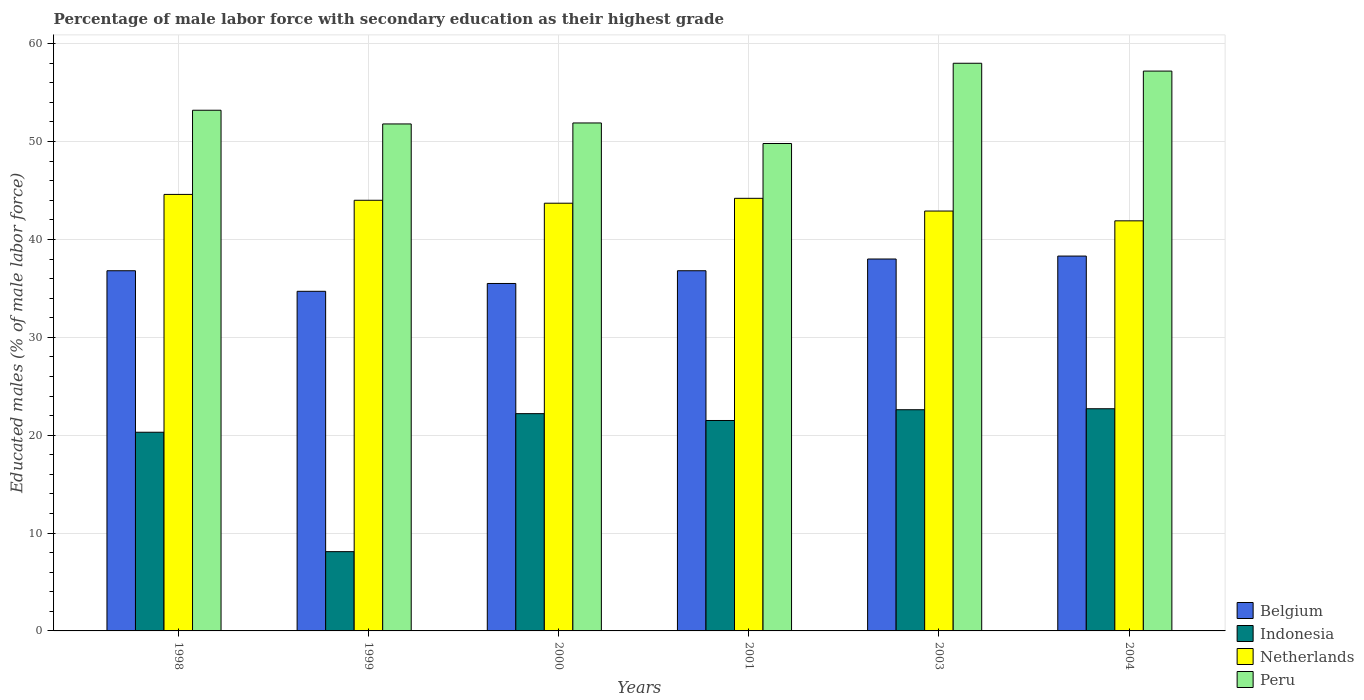How many different coloured bars are there?
Provide a short and direct response. 4. How many groups of bars are there?
Keep it short and to the point. 6. Are the number of bars on each tick of the X-axis equal?
Keep it short and to the point. Yes. How many bars are there on the 6th tick from the right?
Ensure brevity in your answer.  4. What is the label of the 2nd group of bars from the left?
Provide a short and direct response. 1999. What is the percentage of male labor force with secondary education in Belgium in 2004?
Your answer should be very brief. 38.3. Across all years, what is the maximum percentage of male labor force with secondary education in Indonesia?
Make the answer very short. 22.7. Across all years, what is the minimum percentage of male labor force with secondary education in Netherlands?
Give a very brief answer. 41.9. In which year was the percentage of male labor force with secondary education in Peru maximum?
Your response must be concise. 2003. What is the total percentage of male labor force with secondary education in Indonesia in the graph?
Provide a short and direct response. 117.4. What is the difference between the percentage of male labor force with secondary education in Belgium in 1999 and that in 2004?
Offer a very short reply. -3.6. What is the difference between the percentage of male labor force with secondary education in Indonesia in 2000 and the percentage of male labor force with secondary education in Peru in 2003?
Provide a short and direct response. -35.8. What is the average percentage of male labor force with secondary education in Netherlands per year?
Keep it short and to the point. 43.55. In the year 2001, what is the difference between the percentage of male labor force with secondary education in Indonesia and percentage of male labor force with secondary education in Peru?
Provide a short and direct response. -28.3. In how many years, is the percentage of male labor force with secondary education in Indonesia greater than 56 %?
Give a very brief answer. 0. What is the ratio of the percentage of male labor force with secondary education in Belgium in 1998 to that in 1999?
Your answer should be very brief. 1.06. Is the difference between the percentage of male labor force with secondary education in Indonesia in 1998 and 1999 greater than the difference between the percentage of male labor force with secondary education in Peru in 1998 and 1999?
Your answer should be compact. Yes. What is the difference between the highest and the second highest percentage of male labor force with secondary education in Netherlands?
Offer a very short reply. 0.4. What is the difference between the highest and the lowest percentage of male labor force with secondary education in Netherlands?
Keep it short and to the point. 2.7. In how many years, is the percentage of male labor force with secondary education in Peru greater than the average percentage of male labor force with secondary education in Peru taken over all years?
Your answer should be compact. 2. Is the sum of the percentage of male labor force with secondary education in Belgium in 2000 and 2003 greater than the maximum percentage of male labor force with secondary education in Netherlands across all years?
Provide a short and direct response. Yes. Is it the case that in every year, the sum of the percentage of male labor force with secondary education in Indonesia and percentage of male labor force with secondary education in Peru is greater than the sum of percentage of male labor force with secondary education in Netherlands and percentage of male labor force with secondary education in Belgium?
Your answer should be compact. No. What does the 3rd bar from the right in 2001 represents?
Your answer should be very brief. Indonesia. How many bars are there?
Keep it short and to the point. 24. How many years are there in the graph?
Your answer should be compact. 6. How many legend labels are there?
Give a very brief answer. 4. What is the title of the graph?
Make the answer very short. Percentage of male labor force with secondary education as their highest grade. Does "Azerbaijan" appear as one of the legend labels in the graph?
Offer a very short reply. No. What is the label or title of the X-axis?
Your response must be concise. Years. What is the label or title of the Y-axis?
Provide a short and direct response. Educated males (% of male labor force). What is the Educated males (% of male labor force) in Belgium in 1998?
Make the answer very short. 36.8. What is the Educated males (% of male labor force) in Indonesia in 1998?
Your answer should be very brief. 20.3. What is the Educated males (% of male labor force) in Netherlands in 1998?
Keep it short and to the point. 44.6. What is the Educated males (% of male labor force) in Peru in 1998?
Provide a short and direct response. 53.2. What is the Educated males (% of male labor force) in Belgium in 1999?
Your answer should be very brief. 34.7. What is the Educated males (% of male labor force) in Indonesia in 1999?
Your answer should be very brief. 8.1. What is the Educated males (% of male labor force) in Peru in 1999?
Offer a terse response. 51.8. What is the Educated males (% of male labor force) in Belgium in 2000?
Provide a short and direct response. 35.5. What is the Educated males (% of male labor force) of Indonesia in 2000?
Provide a succinct answer. 22.2. What is the Educated males (% of male labor force) of Netherlands in 2000?
Offer a terse response. 43.7. What is the Educated males (% of male labor force) of Peru in 2000?
Offer a terse response. 51.9. What is the Educated males (% of male labor force) in Belgium in 2001?
Offer a terse response. 36.8. What is the Educated males (% of male labor force) of Indonesia in 2001?
Your answer should be compact. 21.5. What is the Educated males (% of male labor force) in Netherlands in 2001?
Your answer should be compact. 44.2. What is the Educated males (% of male labor force) of Peru in 2001?
Offer a very short reply. 49.8. What is the Educated males (% of male labor force) in Belgium in 2003?
Keep it short and to the point. 38. What is the Educated males (% of male labor force) of Indonesia in 2003?
Make the answer very short. 22.6. What is the Educated males (% of male labor force) in Netherlands in 2003?
Offer a very short reply. 42.9. What is the Educated males (% of male labor force) of Belgium in 2004?
Provide a short and direct response. 38.3. What is the Educated males (% of male labor force) of Indonesia in 2004?
Make the answer very short. 22.7. What is the Educated males (% of male labor force) of Netherlands in 2004?
Ensure brevity in your answer.  41.9. What is the Educated males (% of male labor force) in Peru in 2004?
Ensure brevity in your answer.  57.2. Across all years, what is the maximum Educated males (% of male labor force) of Belgium?
Give a very brief answer. 38.3. Across all years, what is the maximum Educated males (% of male labor force) in Indonesia?
Give a very brief answer. 22.7. Across all years, what is the maximum Educated males (% of male labor force) in Netherlands?
Give a very brief answer. 44.6. Across all years, what is the minimum Educated males (% of male labor force) in Belgium?
Your answer should be compact. 34.7. Across all years, what is the minimum Educated males (% of male labor force) of Indonesia?
Offer a very short reply. 8.1. Across all years, what is the minimum Educated males (% of male labor force) of Netherlands?
Keep it short and to the point. 41.9. Across all years, what is the minimum Educated males (% of male labor force) in Peru?
Keep it short and to the point. 49.8. What is the total Educated males (% of male labor force) of Belgium in the graph?
Your answer should be compact. 220.1. What is the total Educated males (% of male labor force) in Indonesia in the graph?
Make the answer very short. 117.4. What is the total Educated males (% of male labor force) of Netherlands in the graph?
Make the answer very short. 261.3. What is the total Educated males (% of male labor force) of Peru in the graph?
Your response must be concise. 321.9. What is the difference between the Educated males (% of male labor force) of Netherlands in 1998 and that in 1999?
Your answer should be very brief. 0.6. What is the difference between the Educated males (% of male labor force) of Belgium in 1998 and that in 2000?
Your response must be concise. 1.3. What is the difference between the Educated males (% of male labor force) in Peru in 1998 and that in 2000?
Make the answer very short. 1.3. What is the difference between the Educated males (% of male labor force) in Belgium in 1998 and that in 2001?
Give a very brief answer. 0. What is the difference between the Educated males (% of male labor force) of Indonesia in 1998 and that in 2001?
Your answer should be very brief. -1.2. What is the difference between the Educated males (% of male labor force) of Netherlands in 1998 and that in 2001?
Ensure brevity in your answer.  0.4. What is the difference between the Educated males (% of male labor force) in Indonesia in 1998 and that in 2003?
Make the answer very short. -2.3. What is the difference between the Educated males (% of male labor force) in Peru in 1998 and that in 2003?
Keep it short and to the point. -4.8. What is the difference between the Educated males (% of male labor force) of Belgium in 1998 and that in 2004?
Provide a short and direct response. -1.5. What is the difference between the Educated males (% of male labor force) of Indonesia in 1998 and that in 2004?
Give a very brief answer. -2.4. What is the difference between the Educated males (% of male labor force) in Peru in 1998 and that in 2004?
Offer a very short reply. -4. What is the difference between the Educated males (% of male labor force) in Belgium in 1999 and that in 2000?
Keep it short and to the point. -0.8. What is the difference between the Educated males (% of male labor force) of Indonesia in 1999 and that in 2000?
Keep it short and to the point. -14.1. What is the difference between the Educated males (% of male labor force) of Peru in 1999 and that in 2000?
Provide a succinct answer. -0.1. What is the difference between the Educated males (% of male labor force) in Belgium in 1999 and that in 2001?
Your answer should be very brief. -2.1. What is the difference between the Educated males (% of male labor force) in Indonesia in 1999 and that in 2001?
Provide a succinct answer. -13.4. What is the difference between the Educated males (% of male labor force) of Netherlands in 1999 and that in 2001?
Provide a short and direct response. -0.2. What is the difference between the Educated males (% of male labor force) of Belgium in 1999 and that in 2003?
Provide a short and direct response. -3.3. What is the difference between the Educated males (% of male labor force) of Indonesia in 1999 and that in 2003?
Your response must be concise. -14.5. What is the difference between the Educated males (% of male labor force) of Indonesia in 1999 and that in 2004?
Offer a very short reply. -14.6. What is the difference between the Educated males (% of male labor force) in Netherlands in 2000 and that in 2001?
Your answer should be compact. -0.5. What is the difference between the Educated males (% of male labor force) in Netherlands in 2000 and that in 2003?
Provide a short and direct response. 0.8. What is the difference between the Educated males (% of male labor force) of Indonesia in 2000 and that in 2004?
Provide a succinct answer. -0.5. What is the difference between the Educated males (% of male labor force) of Netherlands in 2000 and that in 2004?
Make the answer very short. 1.8. What is the difference between the Educated males (% of male labor force) of Belgium in 2001 and that in 2003?
Provide a short and direct response. -1.2. What is the difference between the Educated males (% of male labor force) in Indonesia in 2001 and that in 2003?
Keep it short and to the point. -1.1. What is the difference between the Educated males (% of male labor force) of Netherlands in 2001 and that in 2003?
Keep it short and to the point. 1.3. What is the difference between the Educated males (% of male labor force) in Belgium in 2001 and that in 2004?
Make the answer very short. -1.5. What is the difference between the Educated males (% of male labor force) of Indonesia in 2001 and that in 2004?
Provide a short and direct response. -1.2. What is the difference between the Educated males (% of male labor force) in Peru in 2001 and that in 2004?
Offer a very short reply. -7.4. What is the difference between the Educated males (% of male labor force) of Netherlands in 2003 and that in 2004?
Your answer should be compact. 1. What is the difference between the Educated males (% of male labor force) of Peru in 2003 and that in 2004?
Your answer should be very brief. 0.8. What is the difference between the Educated males (% of male labor force) of Belgium in 1998 and the Educated males (% of male labor force) of Indonesia in 1999?
Your response must be concise. 28.7. What is the difference between the Educated males (% of male labor force) of Belgium in 1998 and the Educated males (% of male labor force) of Netherlands in 1999?
Your answer should be compact. -7.2. What is the difference between the Educated males (% of male labor force) in Indonesia in 1998 and the Educated males (% of male labor force) in Netherlands in 1999?
Offer a terse response. -23.7. What is the difference between the Educated males (% of male labor force) of Indonesia in 1998 and the Educated males (% of male labor force) of Peru in 1999?
Your response must be concise. -31.5. What is the difference between the Educated males (% of male labor force) in Belgium in 1998 and the Educated males (% of male labor force) in Indonesia in 2000?
Keep it short and to the point. 14.6. What is the difference between the Educated males (% of male labor force) in Belgium in 1998 and the Educated males (% of male labor force) in Netherlands in 2000?
Your response must be concise. -6.9. What is the difference between the Educated males (% of male labor force) in Belgium in 1998 and the Educated males (% of male labor force) in Peru in 2000?
Make the answer very short. -15.1. What is the difference between the Educated males (% of male labor force) of Indonesia in 1998 and the Educated males (% of male labor force) of Netherlands in 2000?
Make the answer very short. -23.4. What is the difference between the Educated males (% of male labor force) in Indonesia in 1998 and the Educated males (% of male labor force) in Peru in 2000?
Offer a very short reply. -31.6. What is the difference between the Educated males (% of male labor force) of Netherlands in 1998 and the Educated males (% of male labor force) of Peru in 2000?
Provide a succinct answer. -7.3. What is the difference between the Educated males (% of male labor force) in Belgium in 1998 and the Educated males (% of male labor force) in Indonesia in 2001?
Your answer should be compact. 15.3. What is the difference between the Educated males (% of male labor force) of Belgium in 1998 and the Educated males (% of male labor force) of Peru in 2001?
Provide a short and direct response. -13. What is the difference between the Educated males (% of male labor force) of Indonesia in 1998 and the Educated males (% of male labor force) of Netherlands in 2001?
Offer a very short reply. -23.9. What is the difference between the Educated males (% of male labor force) in Indonesia in 1998 and the Educated males (% of male labor force) in Peru in 2001?
Your answer should be very brief. -29.5. What is the difference between the Educated males (% of male labor force) of Netherlands in 1998 and the Educated males (% of male labor force) of Peru in 2001?
Your response must be concise. -5.2. What is the difference between the Educated males (% of male labor force) in Belgium in 1998 and the Educated males (% of male labor force) in Indonesia in 2003?
Your answer should be compact. 14.2. What is the difference between the Educated males (% of male labor force) in Belgium in 1998 and the Educated males (% of male labor force) in Netherlands in 2003?
Ensure brevity in your answer.  -6.1. What is the difference between the Educated males (% of male labor force) in Belgium in 1998 and the Educated males (% of male labor force) in Peru in 2003?
Offer a very short reply. -21.2. What is the difference between the Educated males (% of male labor force) of Indonesia in 1998 and the Educated males (% of male labor force) of Netherlands in 2003?
Your answer should be very brief. -22.6. What is the difference between the Educated males (% of male labor force) of Indonesia in 1998 and the Educated males (% of male labor force) of Peru in 2003?
Make the answer very short. -37.7. What is the difference between the Educated males (% of male labor force) of Netherlands in 1998 and the Educated males (% of male labor force) of Peru in 2003?
Keep it short and to the point. -13.4. What is the difference between the Educated males (% of male labor force) of Belgium in 1998 and the Educated males (% of male labor force) of Peru in 2004?
Keep it short and to the point. -20.4. What is the difference between the Educated males (% of male labor force) in Indonesia in 1998 and the Educated males (% of male labor force) in Netherlands in 2004?
Offer a terse response. -21.6. What is the difference between the Educated males (% of male labor force) of Indonesia in 1998 and the Educated males (% of male labor force) of Peru in 2004?
Offer a terse response. -36.9. What is the difference between the Educated males (% of male labor force) in Netherlands in 1998 and the Educated males (% of male labor force) in Peru in 2004?
Your response must be concise. -12.6. What is the difference between the Educated males (% of male labor force) in Belgium in 1999 and the Educated males (% of male labor force) in Indonesia in 2000?
Keep it short and to the point. 12.5. What is the difference between the Educated males (% of male labor force) of Belgium in 1999 and the Educated males (% of male labor force) of Netherlands in 2000?
Offer a terse response. -9. What is the difference between the Educated males (% of male labor force) of Belgium in 1999 and the Educated males (% of male labor force) of Peru in 2000?
Keep it short and to the point. -17.2. What is the difference between the Educated males (% of male labor force) in Indonesia in 1999 and the Educated males (% of male labor force) in Netherlands in 2000?
Your answer should be compact. -35.6. What is the difference between the Educated males (% of male labor force) of Indonesia in 1999 and the Educated males (% of male labor force) of Peru in 2000?
Ensure brevity in your answer.  -43.8. What is the difference between the Educated males (% of male labor force) in Netherlands in 1999 and the Educated males (% of male labor force) in Peru in 2000?
Offer a very short reply. -7.9. What is the difference between the Educated males (% of male labor force) of Belgium in 1999 and the Educated males (% of male labor force) of Peru in 2001?
Your answer should be compact. -15.1. What is the difference between the Educated males (% of male labor force) in Indonesia in 1999 and the Educated males (% of male labor force) in Netherlands in 2001?
Provide a short and direct response. -36.1. What is the difference between the Educated males (% of male labor force) in Indonesia in 1999 and the Educated males (% of male labor force) in Peru in 2001?
Your answer should be compact. -41.7. What is the difference between the Educated males (% of male labor force) in Netherlands in 1999 and the Educated males (% of male labor force) in Peru in 2001?
Offer a terse response. -5.8. What is the difference between the Educated males (% of male labor force) of Belgium in 1999 and the Educated males (% of male labor force) of Netherlands in 2003?
Provide a short and direct response. -8.2. What is the difference between the Educated males (% of male labor force) of Belgium in 1999 and the Educated males (% of male labor force) of Peru in 2003?
Give a very brief answer. -23.3. What is the difference between the Educated males (% of male labor force) in Indonesia in 1999 and the Educated males (% of male labor force) in Netherlands in 2003?
Ensure brevity in your answer.  -34.8. What is the difference between the Educated males (% of male labor force) of Indonesia in 1999 and the Educated males (% of male labor force) of Peru in 2003?
Your answer should be compact. -49.9. What is the difference between the Educated males (% of male labor force) of Belgium in 1999 and the Educated males (% of male labor force) of Indonesia in 2004?
Your answer should be very brief. 12. What is the difference between the Educated males (% of male labor force) of Belgium in 1999 and the Educated males (% of male labor force) of Netherlands in 2004?
Make the answer very short. -7.2. What is the difference between the Educated males (% of male labor force) in Belgium in 1999 and the Educated males (% of male labor force) in Peru in 2004?
Offer a very short reply. -22.5. What is the difference between the Educated males (% of male labor force) of Indonesia in 1999 and the Educated males (% of male labor force) of Netherlands in 2004?
Offer a terse response. -33.8. What is the difference between the Educated males (% of male labor force) of Indonesia in 1999 and the Educated males (% of male labor force) of Peru in 2004?
Offer a very short reply. -49.1. What is the difference between the Educated males (% of male labor force) in Netherlands in 1999 and the Educated males (% of male labor force) in Peru in 2004?
Offer a very short reply. -13.2. What is the difference between the Educated males (% of male labor force) in Belgium in 2000 and the Educated males (% of male labor force) in Peru in 2001?
Provide a succinct answer. -14.3. What is the difference between the Educated males (% of male labor force) in Indonesia in 2000 and the Educated males (% of male labor force) in Netherlands in 2001?
Keep it short and to the point. -22. What is the difference between the Educated males (% of male labor force) in Indonesia in 2000 and the Educated males (% of male labor force) in Peru in 2001?
Provide a succinct answer. -27.6. What is the difference between the Educated males (% of male labor force) of Belgium in 2000 and the Educated males (% of male labor force) of Peru in 2003?
Your answer should be compact. -22.5. What is the difference between the Educated males (% of male labor force) of Indonesia in 2000 and the Educated males (% of male labor force) of Netherlands in 2003?
Offer a terse response. -20.7. What is the difference between the Educated males (% of male labor force) of Indonesia in 2000 and the Educated males (% of male labor force) of Peru in 2003?
Offer a very short reply. -35.8. What is the difference between the Educated males (% of male labor force) of Netherlands in 2000 and the Educated males (% of male labor force) of Peru in 2003?
Keep it short and to the point. -14.3. What is the difference between the Educated males (% of male labor force) of Belgium in 2000 and the Educated males (% of male labor force) of Netherlands in 2004?
Your answer should be very brief. -6.4. What is the difference between the Educated males (% of male labor force) in Belgium in 2000 and the Educated males (% of male labor force) in Peru in 2004?
Your answer should be very brief. -21.7. What is the difference between the Educated males (% of male labor force) in Indonesia in 2000 and the Educated males (% of male labor force) in Netherlands in 2004?
Your answer should be very brief. -19.7. What is the difference between the Educated males (% of male labor force) in Indonesia in 2000 and the Educated males (% of male labor force) in Peru in 2004?
Offer a very short reply. -35. What is the difference between the Educated males (% of male labor force) of Netherlands in 2000 and the Educated males (% of male labor force) of Peru in 2004?
Your answer should be very brief. -13.5. What is the difference between the Educated males (% of male labor force) of Belgium in 2001 and the Educated males (% of male labor force) of Indonesia in 2003?
Ensure brevity in your answer.  14.2. What is the difference between the Educated males (% of male labor force) in Belgium in 2001 and the Educated males (% of male labor force) in Netherlands in 2003?
Offer a terse response. -6.1. What is the difference between the Educated males (% of male labor force) in Belgium in 2001 and the Educated males (% of male labor force) in Peru in 2003?
Your response must be concise. -21.2. What is the difference between the Educated males (% of male labor force) in Indonesia in 2001 and the Educated males (% of male labor force) in Netherlands in 2003?
Ensure brevity in your answer.  -21.4. What is the difference between the Educated males (% of male labor force) in Indonesia in 2001 and the Educated males (% of male labor force) in Peru in 2003?
Provide a short and direct response. -36.5. What is the difference between the Educated males (% of male labor force) in Belgium in 2001 and the Educated males (% of male labor force) in Indonesia in 2004?
Your answer should be compact. 14.1. What is the difference between the Educated males (% of male labor force) of Belgium in 2001 and the Educated males (% of male labor force) of Netherlands in 2004?
Keep it short and to the point. -5.1. What is the difference between the Educated males (% of male labor force) of Belgium in 2001 and the Educated males (% of male labor force) of Peru in 2004?
Ensure brevity in your answer.  -20.4. What is the difference between the Educated males (% of male labor force) in Indonesia in 2001 and the Educated males (% of male labor force) in Netherlands in 2004?
Offer a terse response. -20.4. What is the difference between the Educated males (% of male labor force) of Indonesia in 2001 and the Educated males (% of male labor force) of Peru in 2004?
Offer a very short reply. -35.7. What is the difference between the Educated males (% of male labor force) in Netherlands in 2001 and the Educated males (% of male labor force) in Peru in 2004?
Your response must be concise. -13. What is the difference between the Educated males (% of male labor force) in Belgium in 2003 and the Educated males (% of male labor force) in Indonesia in 2004?
Keep it short and to the point. 15.3. What is the difference between the Educated males (% of male labor force) in Belgium in 2003 and the Educated males (% of male labor force) in Peru in 2004?
Your answer should be very brief. -19.2. What is the difference between the Educated males (% of male labor force) in Indonesia in 2003 and the Educated males (% of male labor force) in Netherlands in 2004?
Your response must be concise. -19.3. What is the difference between the Educated males (% of male labor force) of Indonesia in 2003 and the Educated males (% of male labor force) of Peru in 2004?
Provide a succinct answer. -34.6. What is the difference between the Educated males (% of male labor force) in Netherlands in 2003 and the Educated males (% of male labor force) in Peru in 2004?
Offer a terse response. -14.3. What is the average Educated males (% of male labor force) in Belgium per year?
Provide a short and direct response. 36.68. What is the average Educated males (% of male labor force) of Indonesia per year?
Provide a succinct answer. 19.57. What is the average Educated males (% of male labor force) of Netherlands per year?
Provide a short and direct response. 43.55. What is the average Educated males (% of male labor force) in Peru per year?
Your answer should be compact. 53.65. In the year 1998, what is the difference between the Educated males (% of male labor force) in Belgium and Educated males (% of male labor force) in Indonesia?
Give a very brief answer. 16.5. In the year 1998, what is the difference between the Educated males (% of male labor force) of Belgium and Educated males (% of male labor force) of Peru?
Your answer should be very brief. -16.4. In the year 1998, what is the difference between the Educated males (% of male labor force) of Indonesia and Educated males (% of male labor force) of Netherlands?
Offer a very short reply. -24.3. In the year 1998, what is the difference between the Educated males (% of male labor force) in Indonesia and Educated males (% of male labor force) in Peru?
Offer a terse response. -32.9. In the year 1998, what is the difference between the Educated males (% of male labor force) of Netherlands and Educated males (% of male labor force) of Peru?
Provide a short and direct response. -8.6. In the year 1999, what is the difference between the Educated males (% of male labor force) in Belgium and Educated males (% of male labor force) in Indonesia?
Keep it short and to the point. 26.6. In the year 1999, what is the difference between the Educated males (% of male labor force) of Belgium and Educated males (% of male labor force) of Netherlands?
Ensure brevity in your answer.  -9.3. In the year 1999, what is the difference between the Educated males (% of male labor force) of Belgium and Educated males (% of male labor force) of Peru?
Provide a succinct answer. -17.1. In the year 1999, what is the difference between the Educated males (% of male labor force) of Indonesia and Educated males (% of male labor force) of Netherlands?
Keep it short and to the point. -35.9. In the year 1999, what is the difference between the Educated males (% of male labor force) of Indonesia and Educated males (% of male labor force) of Peru?
Keep it short and to the point. -43.7. In the year 1999, what is the difference between the Educated males (% of male labor force) in Netherlands and Educated males (% of male labor force) in Peru?
Keep it short and to the point. -7.8. In the year 2000, what is the difference between the Educated males (% of male labor force) of Belgium and Educated males (% of male labor force) of Netherlands?
Ensure brevity in your answer.  -8.2. In the year 2000, what is the difference between the Educated males (% of male labor force) in Belgium and Educated males (% of male labor force) in Peru?
Give a very brief answer. -16.4. In the year 2000, what is the difference between the Educated males (% of male labor force) of Indonesia and Educated males (% of male labor force) of Netherlands?
Provide a short and direct response. -21.5. In the year 2000, what is the difference between the Educated males (% of male labor force) of Indonesia and Educated males (% of male labor force) of Peru?
Your answer should be very brief. -29.7. In the year 2001, what is the difference between the Educated males (% of male labor force) of Belgium and Educated males (% of male labor force) of Peru?
Your answer should be compact. -13. In the year 2001, what is the difference between the Educated males (% of male labor force) of Indonesia and Educated males (% of male labor force) of Netherlands?
Offer a terse response. -22.7. In the year 2001, what is the difference between the Educated males (% of male labor force) in Indonesia and Educated males (% of male labor force) in Peru?
Ensure brevity in your answer.  -28.3. In the year 2003, what is the difference between the Educated males (% of male labor force) in Belgium and Educated males (% of male labor force) in Indonesia?
Your response must be concise. 15.4. In the year 2003, what is the difference between the Educated males (% of male labor force) of Belgium and Educated males (% of male labor force) of Netherlands?
Your response must be concise. -4.9. In the year 2003, what is the difference between the Educated males (% of male labor force) of Indonesia and Educated males (% of male labor force) of Netherlands?
Provide a short and direct response. -20.3. In the year 2003, what is the difference between the Educated males (% of male labor force) in Indonesia and Educated males (% of male labor force) in Peru?
Ensure brevity in your answer.  -35.4. In the year 2003, what is the difference between the Educated males (% of male labor force) in Netherlands and Educated males (% of male labor force) in Peru?
Ensure brevity in your answer.  -15.1. In the year 2004, what is the difference between the Educated males (% of male labor force) in Belgium and Educated males (% of male labor force) in Indonesia?
Your answer should be compact. 15.6. In the year 2004, what is the difference between the Educated males (% of male labor force) of Belgium and Educated males (% of male labor force) of Netherlands?
Make the answer very short. -3.6. In the year 2004, what is the difference between the Educated males (% of male labor force) of Belgium and Educated males (% of male labor force) of Peru?
Offer a very short reply. -18.9. In the year 2004, what is the difference between the Educated males (% of male labor force) in Indonesia and Educated males (% of male labor force) in Netherlands?
Keep it short and to the point. -19.2. In the year 2004, what is the difference between the Educated males (% of male labor force) in Indonesia and Educated males (% of male labor force) in Peru?
Keep it short and to the point. -34.5. In the year 2004, what is the difference between the Educated males (% of male labor force) in Netherlands and Educated males (% of male labor force) in Peru?
Offer a very short reply. -15.3. What is the ratio of the Educated males (% of male labor force) in Belgium in 1998 to that in 1999?
Your answer should be compact. 1.06. What is the ratio of the Educated males (% of male labor force) in Indonesia in 1998 to that in 1999?
Make the answer very short. 2.51. What is the ratio of the Educated males (% of male labor force) of Netherlands in 1998 to that in 1999?
Your answer should be very brief. 1.01. What is the ratio of the Educated males (% of male labor force) of Belgium in 1998 to that in 2000?
Ensure brevity in your answer.  1.04. What is the ratio of the Educated males (% of male labor force) of Indonesia in 1998 to that in 2000?
Give a very brief answer. 0.91. What is the ratio of the Educated males (% of male labor force) in Netherlands in 1998 to that in 2000?
Give a very brief answer. 1.02. What is the ratio of the Educated males (% of male labor force) of Belgium in 1998 to that in 2001?
Your response must be concise. 1. What is the ratio of the Educated males (% of male labor force) in Indonesia in 1998 to that in 2001?
Keep it short and to the point. 0.94. What is the ratio of the Educated males (% of male labor force) in Peru in 1998 to that in 2001?
Offer a very short reply. 1.07. What is the ratio of the Educated males (% of male labor force) in Belgium in 1998 to that in 2003?
Offer a very short reply. 0.97. What is the ratio of the Educated males (% of male labor force) of Indonesia in 1998 to that in 2003?
Your answer should be very brief. 0.9. What is the ratio of the Educated males (% of male labor force) in Netherlands in 1998 to that in 2003?
Ensure brevity in your answer.  1.04. What is the ratio of the Educated males (% of male labor force) in Peru in 1998 to that in 2003?
Keep it short and to the point. 0.92. What is the ratio of the Educated males (% of male labor force) of Belgium in 1998 to that in 2004?
Provide a short and direct response. 0.96. What is the ratio of the Educated males (% of male labor force) in Indonesia in 1998 to that in 2004?
Your answer should be compact. 0.89. What is the ratio of the Educated males (% of male labor force) in Netherlands in 1998 to that in 2004?
Offer a terse response. 1.06. What is the ratio of the Educated males (% of male labor force) in Peru in 1998 to that in 2004?
Give a very brief answer. 0.93. What is the ratio of the Educated males (% of male labor force) of Belgium in 1999 to that in 2000?
Your answer should be compact. 0.98. What is the ratio of the Educated males (% of male labor force) of Indonesia in 1999 to that in 2000?
Keep it short and to the point. 0.36. What is the ratio of the Educated males (% of male labor force) in Belgium in 1999 to that in 2001?
Make the answer very short. 0.94. What is the ratio of the Educated males (% of male labor force) in Indonesia in 1999 to that in 2001?
Your answer should be very brief. 0.38. What is the ratio of the Educated males (% of male labor force) in Netherlands in 1999 to that in 2001?
Keep it short and to the point. 1. What is the ratio of the Educated males (% of male labor force) in Peru in 1999 to that in 2001?
Give a very brief answer. 1.04. What is the ratio of the Educated males (% of male labor force) of Belgium in 1999 to that in 2003?
Give a very brief answer. 0.91. What is the ratio of the Educated males (% of male labor force) in Indonesia in 1999 to that in 2003?
Keep it short and to the point. 0.36. What is the ratio of the Educated males (% of male labor force) of Netherlands in 1999 to that in 2003?
Your answer should be very brief. 1.03. What is the ratio of the Educated males (% of male labor force) of Peru in 1999 to that in 2003?
Your answer should be compact. 0.89. What is the ratio of the Educated males (% of male labor force) of Belgium in 1999 to that in 2004?
Provide a short and direct response. 0.91. What is the ratio of the Educated males (% of male labor force) in Indonesia in 1999 to that in 2004?
Offer a terse response. 0.36. What is the ratio of the Educated males (% of male labor force) in Netherlands in 1999 to that in 2004?
Keep it short and to the point. 1.05. What is the ratio of the Educated males (% of male labor force) of Peru in 1999 to that in 2004?
Keep it short and to the point. 0.91. What is the ratio of the Educated males (% of male labor force) of Belgium in 2000 to that in 2001?
Ensure brevity in your answer.  0.96. What is the ratio of the Educated males (% of male labor force) of Indonesia in 2000 to that in 2001?
Provide a short and direct response. 1.03. What is the ratio of the Educated males (% of male labor force) in Netherlands in 2000 to that in 2001?
Ensure brevity in your answer.  0.99. What is the ratio of the Educated males (% of male labor force) in Peru in 2000 to that in 2001?
Provide a succinct answer. 1.04. What is the ratio of the Educated males (% of male labor force) in Belgium in 2000 to that in 2003?
Offer a terse response. 0.93. What is the ratio of the Educated males (% of male labor force) of Indonesia in 2000 to that in 2003?
Make the answer very short. 0.98. What is the ratio of the Educated males (% of male labor force) of Netherlands in 2000 to that in 2003?
Offer a terse response. 1.02. What is the ratio of the Educated males (% of male labor force) in Peru in 2000 to that in 2003?
Your answer should be very brief. 0.89. What is the ratio of the Educated males (% of male labor force) in Belgium in 2000 to that in 2004?
Your response must be concise. 0.93. What is the ratio of the Educated males (% of male labor force) in Indonesia in 2000 to that in 2004?
Offer a very short reply. 0.98. What is the ratio of the Educated males (% of male labor force) in Netherlands in 2000 to that in 2004?
Offer a terse response. 1.04. What is the ratio of the Educated males (% of male labor force) in Peru in 2000 to that in 2004?
Provide a short and direct response. 0.91. What is the ratio of the Educated males (% of male labor force) of Belgium in 2001 to that in 2003?
Offer a very short reply. 0.97. What is the ratio of the Educated males (% of male labor force) of Indonesia in 2001 to that in 2003?
Your response must be concise. 0.95. What is the ratio of the Educated males (% of male labor force) of Netherlands in 2001 to that in 2003?
Keep it short and to the point. 1.03. What is the ratio of the Educated males (% of male labor force) in Peru in 2001 to that in 2003?
Provide a short and direct response. 0.86. What is the ratio of the Educated males (% of male labor force) in Belgium in 2001 to that in 2004?
Provide a short and direct response. 0.96. What is the ratio of the Educated males (% of male labor force) of Indonesia in 2001 to that in 2004?
Make the answer very short. 0.95. What is the ratio of the Educated males (% of male labor force) of Netherlands in 2001 to that in 2004?
Keep it short and to the point. 1.05. What is the ratio of the Educated males (% of male labor force) of Peru in 2001 to that in 2004?
Provide a short and direct response. 0.87. What is the ratio of the Educated males (% of male labor force) of Belgium in 2003 to that in 2004?
Make the answer very short. 0.99. What is the ratio of the Educated males (% of male labor force) of Netherlands in 2003 to that in 2004?
Your answer should be compact. 1.02. What is the ratio of the Educated males (% of male labor force) of Peru in 2003 to that in 2004?
Provide a succinct answer. 1.01. What is the difference between the highest and the second highest Educated males (% of male labor force) of Belgium?
Provide a succinct answer. 0.3. What is the difference between the highest and the lowest Educated males (% of male labor force) of Belgium?
Offer a terse response. 3.6. What is the difference between the highest and the lowest Educated males (% of male labor force) in Indonesia?
Offer a terse response. 14.6. What is the difference between the highest and the lowest Educated males (% of male labor force) of Netherlands?
Provide a succinct answer. 2.7. 